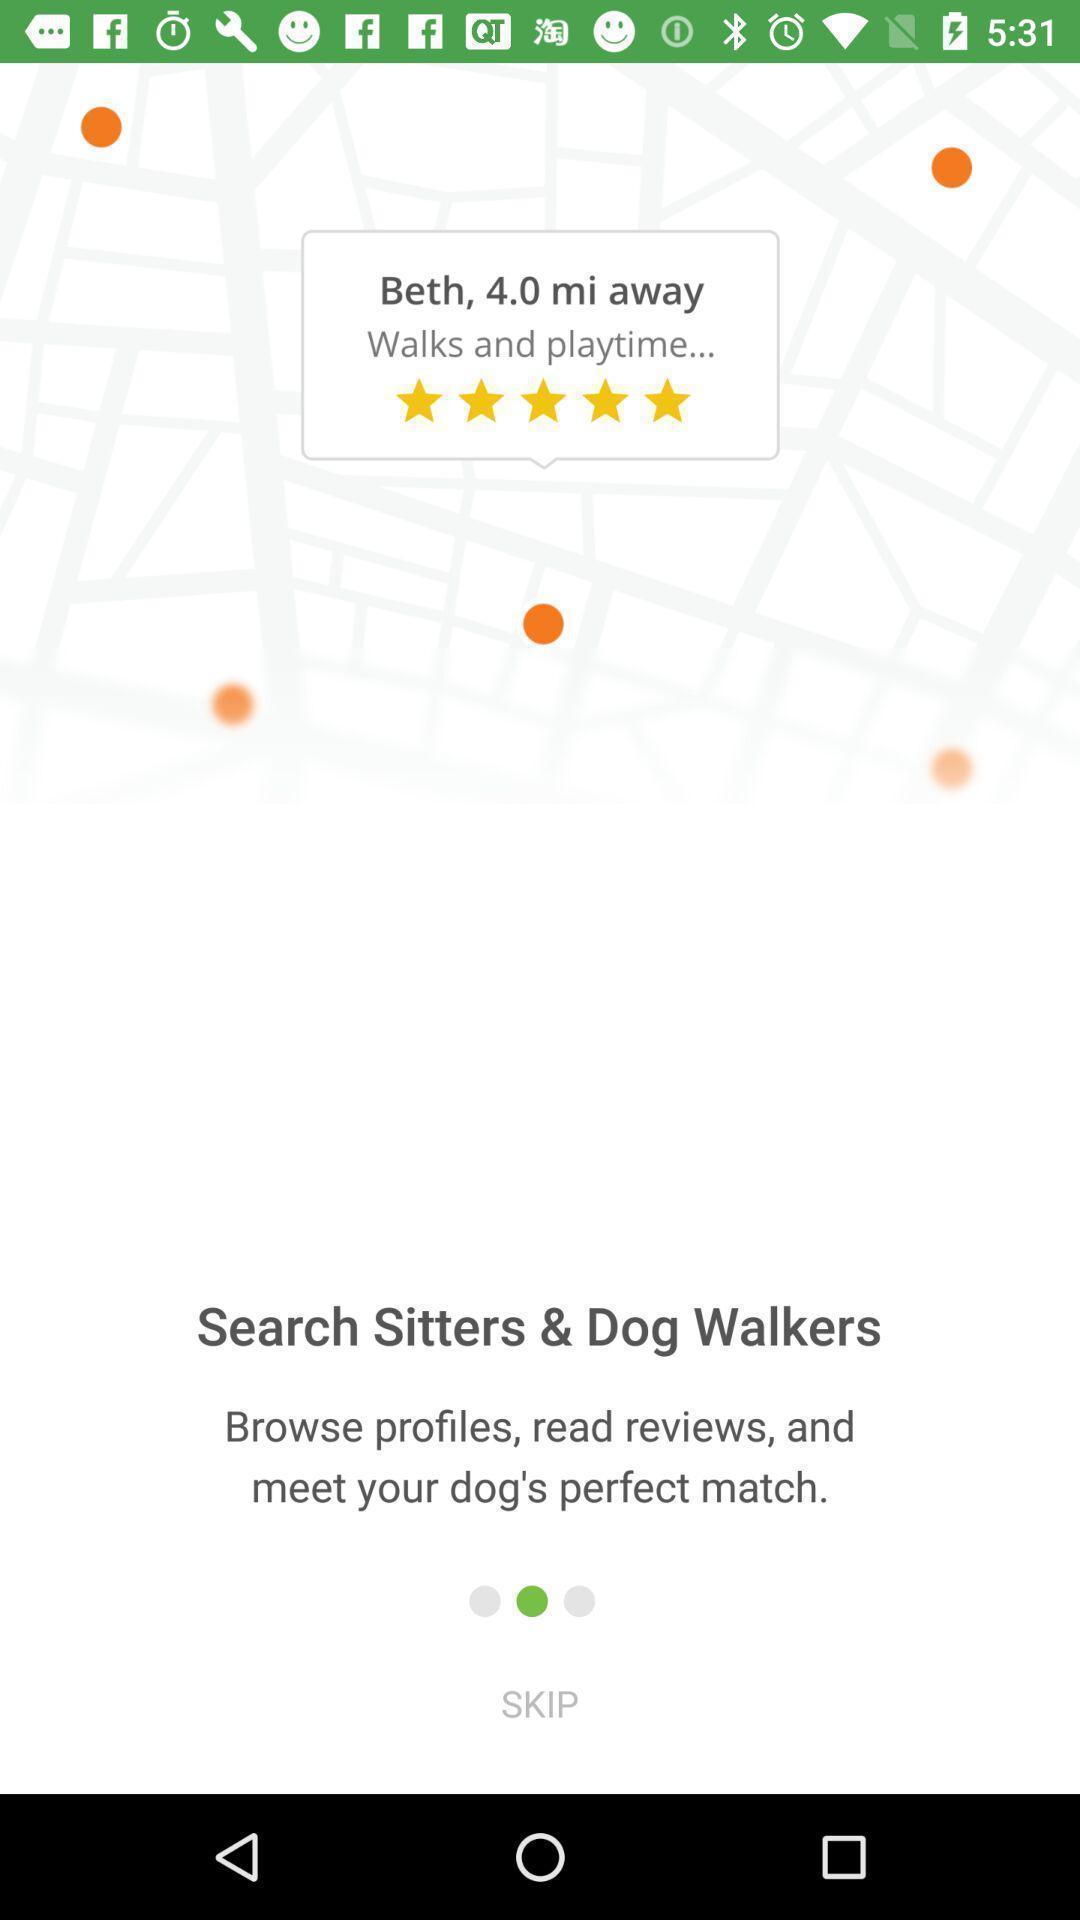Provide a detailed account of this screenshot. Rating page displaying. 